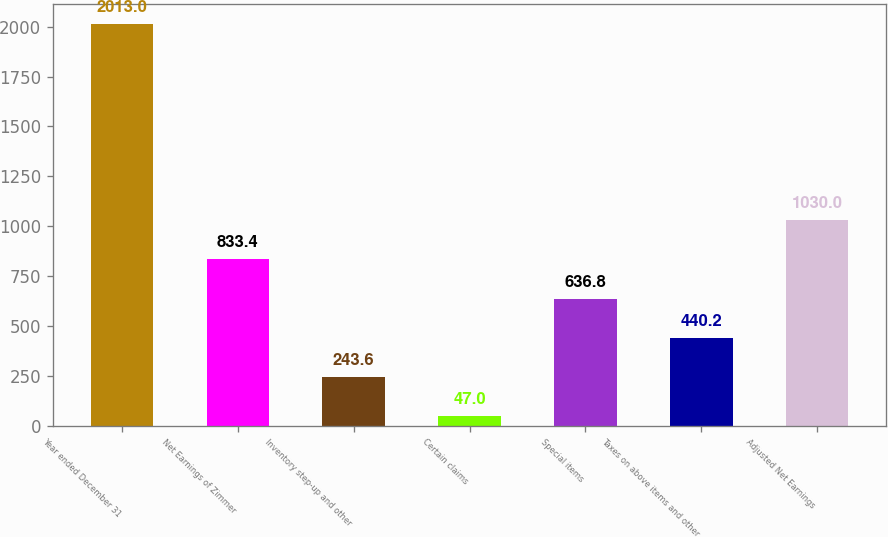<chart> <loc_0><loc_0><loc_500><loc_500><bar_chart><fcel>Year ended December 31<fcel>Net Earnings of Zimmer<fcel>Inventory step-up and other<fcel>Certain claims<fcel>Special items<fcel>Taxes on above items and other<fcel>Adjusted Net Earnings<nl><fcel>2013<fcel>833.4<fcel>243.6<fcel>47<fcel>636.8<fcel>440.2<fcel>1030<nl></chart> 